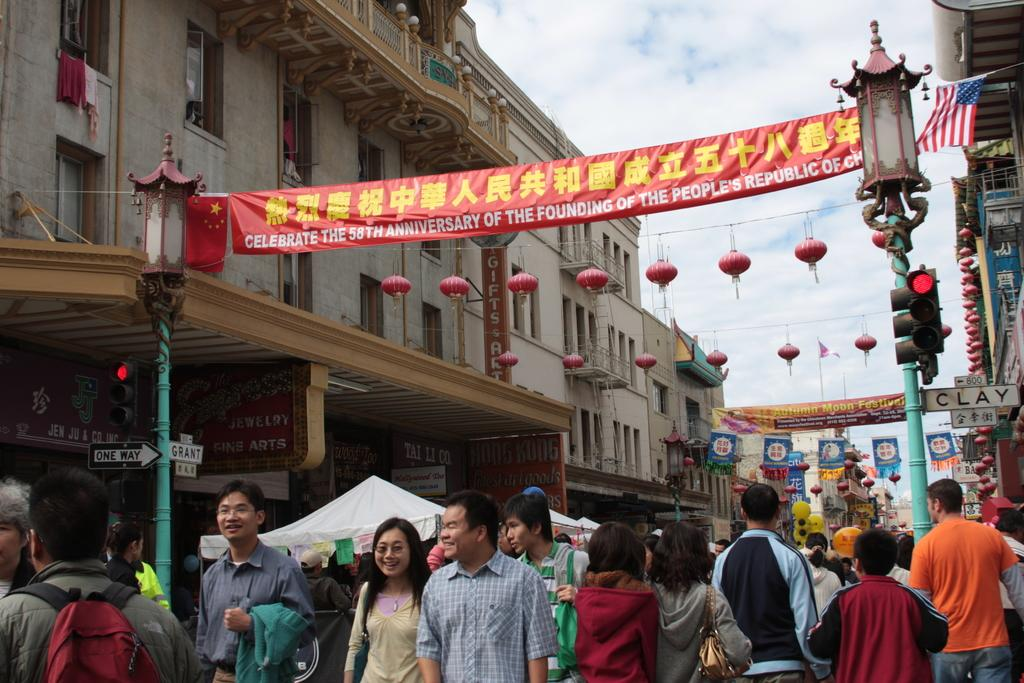How many people are in the group visible in the image? The number of people in the group cannot be determined from the provided facts. What type of temporary shelters can be seen in the image? There are tents in the image. What type of infrastructure is visible in the image? Electric poles, buildings, and name boards are visible in the image. What type of decorations or signage is present in the image? Banners, flags, and posters are present in the image. What is visible in the background of the image? The sky is visible in the background of the image. Can you hear the squirrel laughing in the image? There is no squirrel or laughter present in the image. How does the image show that the people care about the environment? The provided facts do not indicate any information about the people's concern for the environment. 